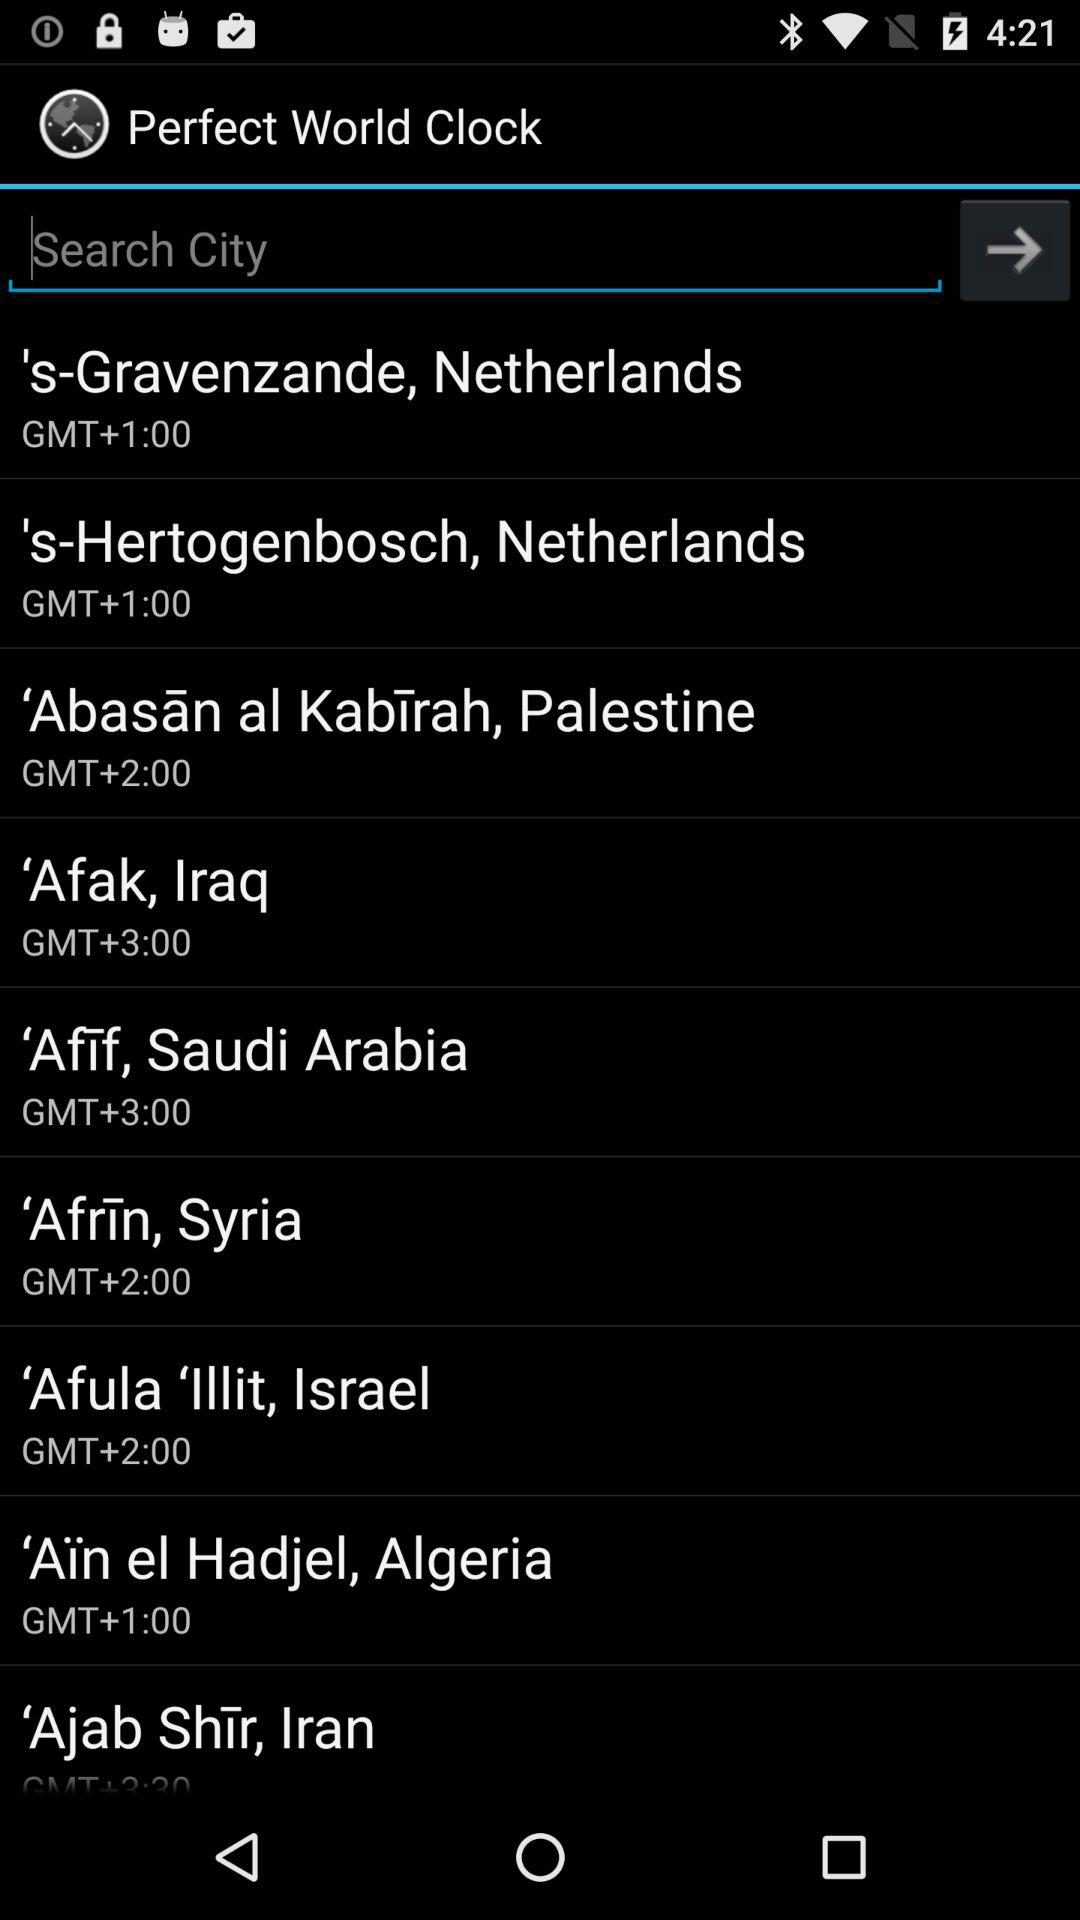What is the application name? The application name is "Perfect World Clock". 